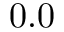<formula> <loc_0><loc_0><loc_500><loc_500>0 . 0</formula> 